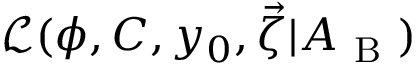<formula> <loc_0><loc_0><loc_500><loc_500>\mathcal { L } ( \phi , C , y _ { 0 } , \vec { \zeta } | A _ { B } )</formula> 